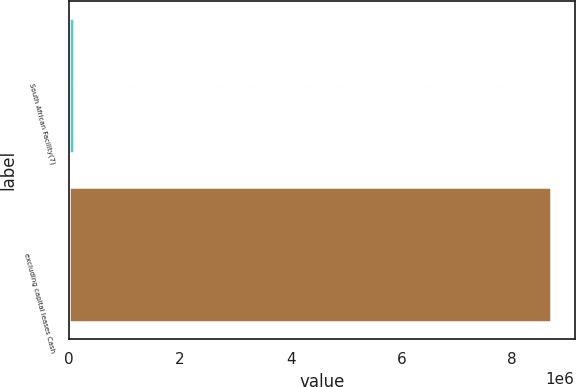<chart> <loc_0><loc_0><loc_500><loc_500><bar_chart><fcel>South African Facility(7)<fcel>excluding capital leases Cash<nl><fcel>98456<fcel>8.69212e+06<nl></chart> 